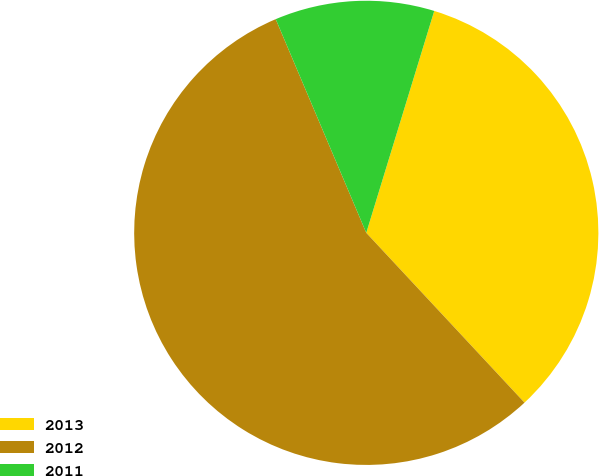Convert chart to OTSL. <chart><loc_0><loc_0><loc_500><loc_500><pie_chart><fcel>2013<fcel>2012<fcel>2011<nl><fcel>33.33%<fcel>55.56%<fcel>11.11%<nl></chart> 